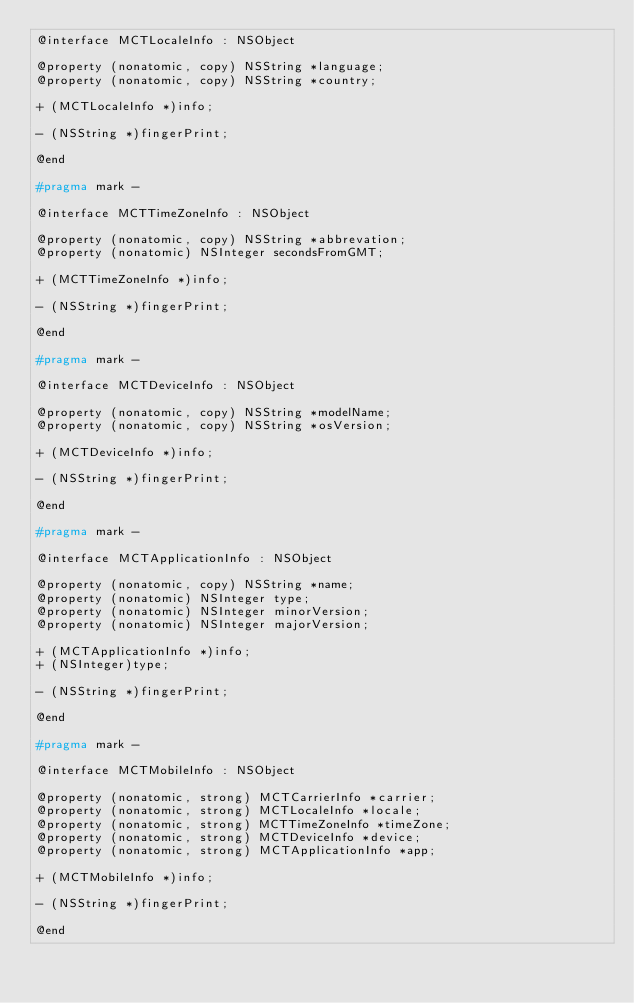Convert code to text. <code><loc_0><loc_0><loc_500><loc_500><_C_>@interface MCTLocaleInfo : NSObject

@property (nonatomic, copy) NSString *language;
@property (nonatomic, copy) NSString *country;

+ (MCTLocaleInfo *)info;

- (NSString *)fingerPrint;

@end

#pragma mark -

@interface MCTTimeZoneInfo : NSObject

@property (nonatomic, copy) NSString *abbrevation;
@property (nonatomic) NSInteger secondsFromGMT;

+ (MCTTimeZoneInfo *)info;

- (NSString *)fingerPrint;

@end

#pragma mark -

@interface MCTDeviceInfo : NSObject

@property (nonatomic, copy) NSString *modelName;
@property (nonatomic, copy) NSString *osVersion;

+ (MCTDeviceInfo *)info;

- (NSString *)fingerPrint;

@end

#pragma mark -

@interface MCTApplicationInfo : NSObject

@property (nonatomic, copy) NSString *name;
@property (nonatomic) NSInteger type;
@property (nonatomic) NSInteger minorVersion;
@property (nonatomic) NSInteger majorVersion;

+ (MCTApplicationInfo *)info;
+ (NSInteger)type;

- (NSString *)fingerPrint;

@end

#pragma mark -

@interface MCTMobileInfo : NSObject

@property (nonatomic, strong) MCTCarrierInfo *carrier;
@property (nonatomic, strong) MCTLocaleInfo *locale;
@property (nonatomic, strong) MCTTimeZoneInfo *timeZone;
@property (nonatomic, strong) MCTDeviceInfo *device;
@property (nonatomic, strong) MCTApplicationInfo *app;

+ (MCTMobileInfo *)info;

- (NSString *)fingerPrint;

@end</code> 